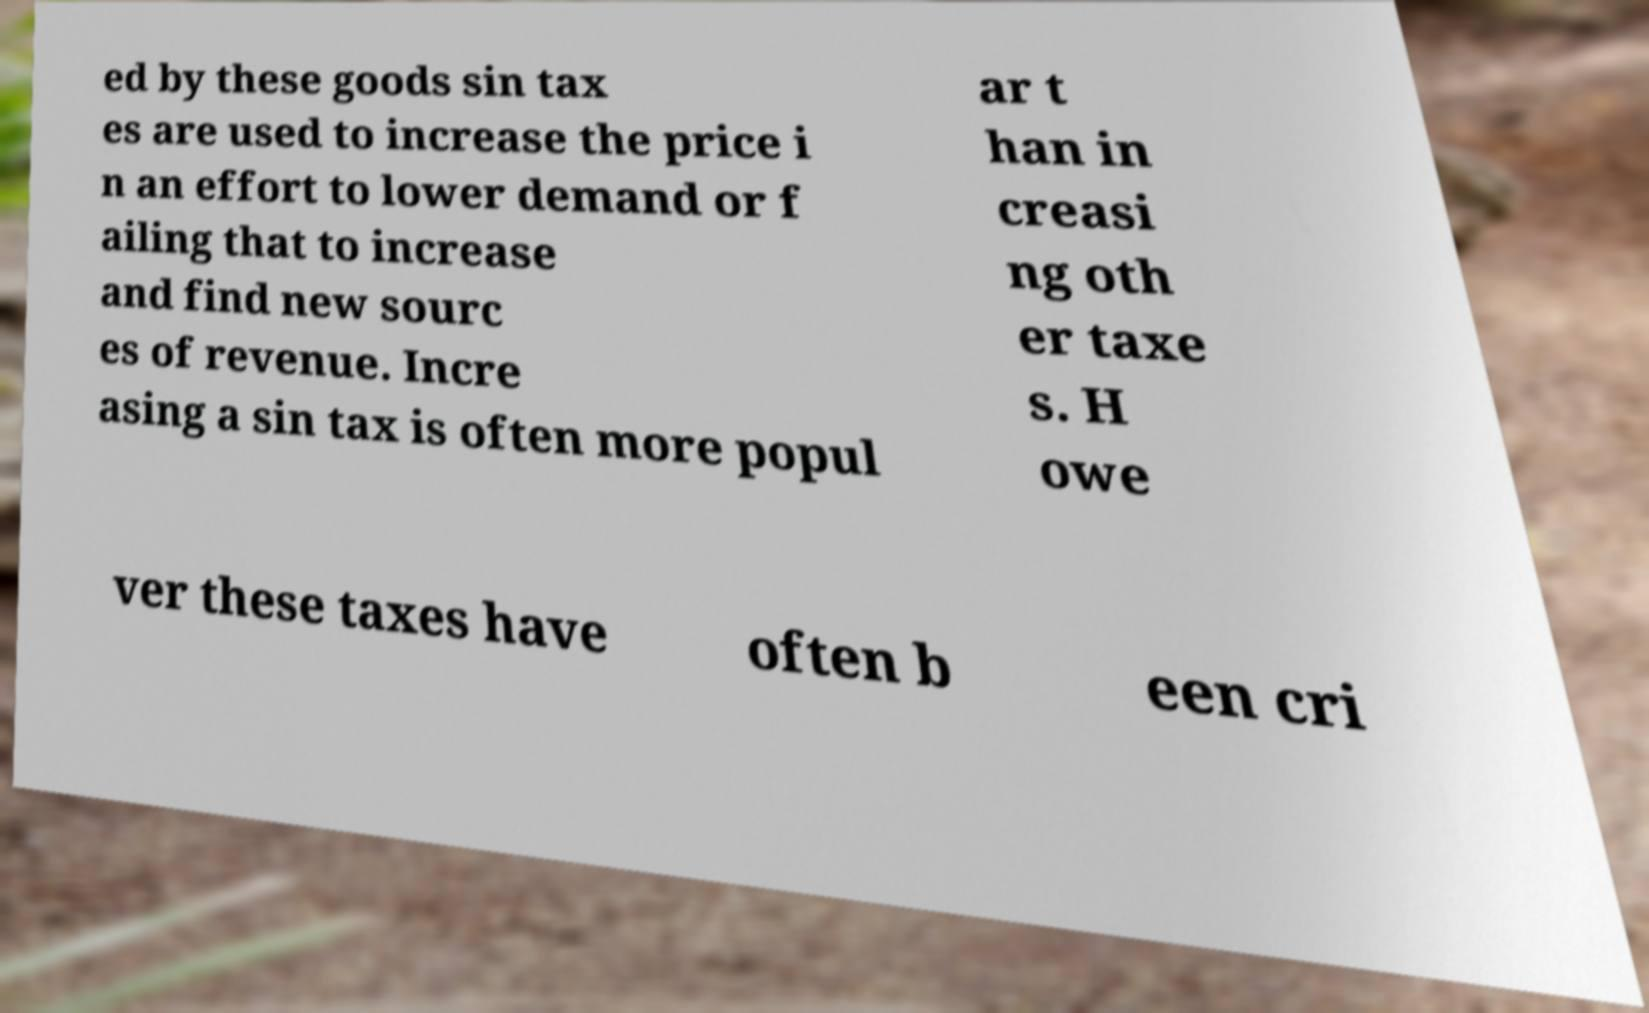I need the written content from this picture converted into text. Can you do that? ed by these goods sin tax es are used to increase the price i n an effort to lower demand or f ailing that to increase and find new sourc es of revenue. Incre asing a sin tax is often more popul ar t han in creasi ng oth er taxe s. H owe ver these taxes have often b een cri 